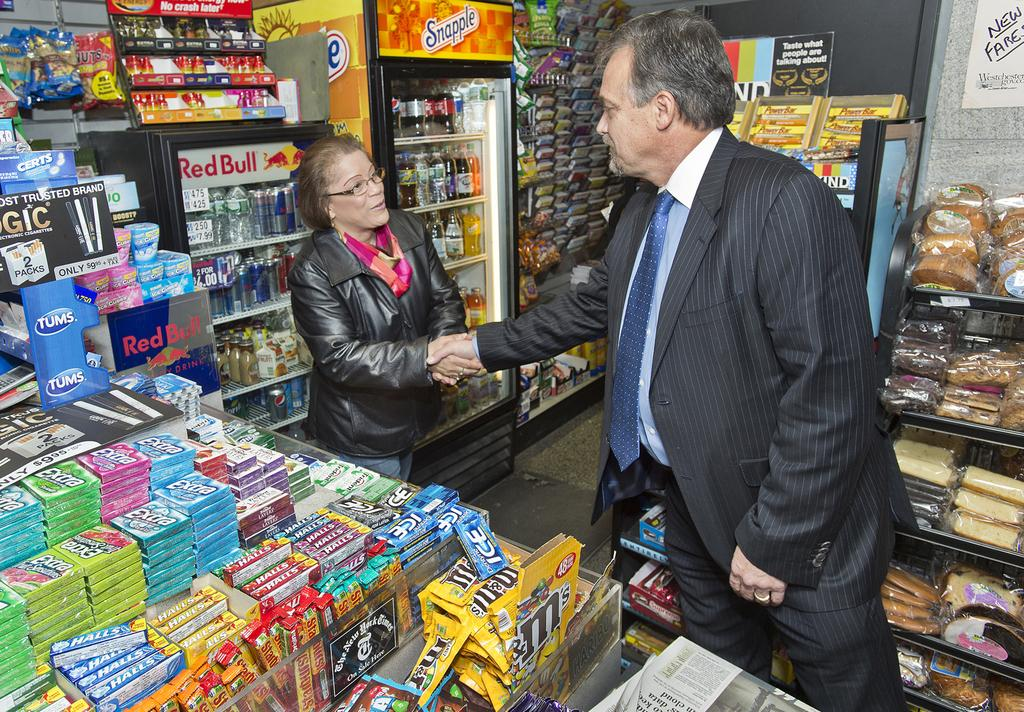<image>
Give a short and clear explanation of the subsequent image. A man in a suit shakes the hand of woman standing in front of a red bull branded fridge. 